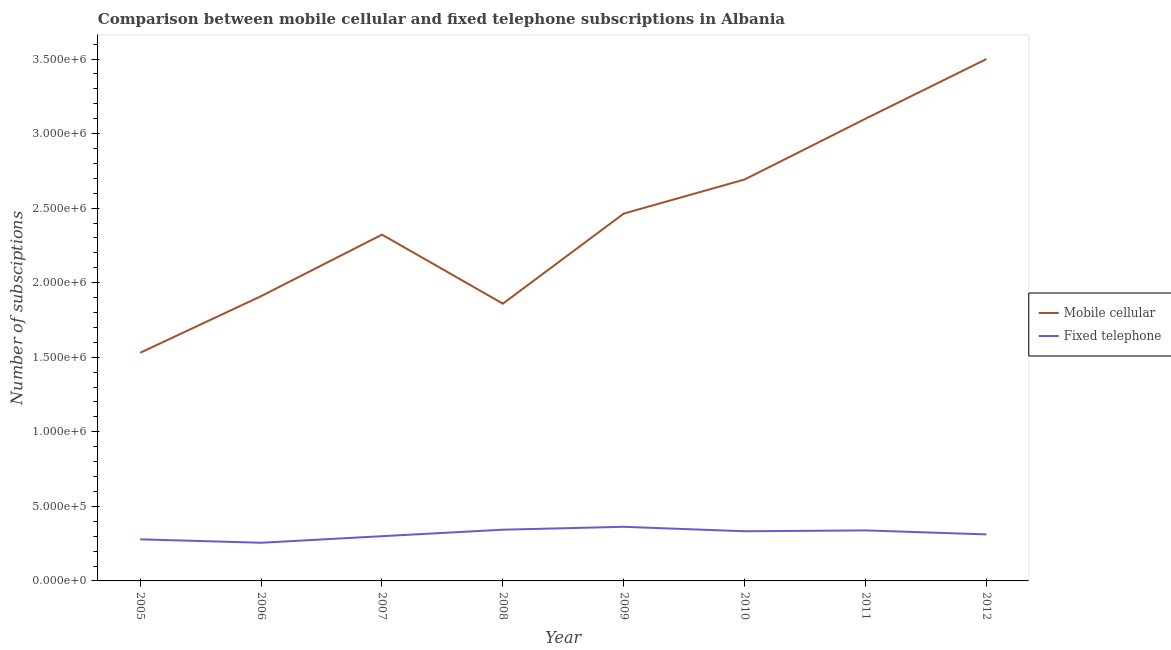How many different coloured lines are there?
Offer a very short reply. 2. Is the number of lines equal to the number of legend labels?
Make the answer very short. Yes. What is the number of fixed telephone subscriptions in 2006?
Your response must be concise. 2.56e+05. Across all years, what is the maximum number of fixed telephone subscriptions?
Your answer should be very brief. 3.63e+05. Across all years, what is the minimum number of mobile cellular subscriptions?
Your response must be concise. 1.53e+06. In which year was the number of mobile cellular subscriptions maximum?
Offer a terse response. 2012. What is the total number of mobile cellular subscriptions in the graph?
Your answer should be very brief. 1.94e+07. What is the difference between the number of mobile cellular subscriptions in 2009 and that in 2011?
Your answer should be very brief. -6.36e+05. What is the difference between the number of mobile cellular subscriptions in 2007 and the number of fixed telephone subscriptions in 2005?
Offer a terse response. 2.04e+06. What is the average number of fixed telephone subscriptions per year?
Your answer should be very brief. 3.16e+05. In the year 2010, what is the difference between the number of fixed telephone subscriptions and number of mobile cellular subscriptions?
Make the answer very short. -2.36e+06. What is the ratio of the number of fixed telephone subscriptions in 2006 to that in 2009?
Ensure brevity in your answer.  0.71. Is the difference between the number of fixed telephone subscriptions in 2005 and 2011 greater than the difference between the number of mobile cellular subscriptions in 2005 and 2011?
Ensure brevity in your answer.  Yes. What is the difference between the highest and the lowest number of mobile cellular subscriptions?
Your answer should be very brief. 1.97e+06. Does the number of mobile cellular subscriptions monotonically increase over the years?
Provide a short and direct response. No. How many lines are there?
Keep it short and to the point. 2. What is the difference between two consecutive major ticks on the Y-axis?
Your response must be concise. 5.00e+05. Are the values on the major ticks of Y-axis written in scientific E-notation?
Your answer should be compact. Yes. Does the graph contain any zero values?
Give a very brief answer. No. Where does the legend appear in the graph?
Ensure brevity in your answer.  Center right. How many legend labels are there?
Provide a succinct answer. 2. What is the title of the graph?
Your answer should be compact. Comparison between mobile cellular and fixed telephone subscriptions in Albania. Does "By country of origin" appear as one of the legend labels in the graph?
Keep it short and to the point. No. What is the label or title of the X-axis?
Your answer should be very brief. Year. What is the label or title of the Y-axis?
Your response must be concise. Number of subsciptions. What is the Number of subsciptions of Mobile cellular in 2005?
Keep it short and to the point. 1.53e+06. What is the Number of subsciptions in Fixed telephone in 2005?
Give a very brief answer. 2.79e+05. What is the Number of subsciptions of Mobile cellular in 2006?
Keep it short and to the point. 1.91e+06. What is the Number of subsciptions in Fixed telephone in 2006?
Give a very brief answer. 2.56e+05. What is the Number of subsciptions of Mobile cellular in 2007?
Make the answer very short. 2.32e+06. What is the Number of subsciptions of Mobile cellular in 2008?
Provide a short and direct response. 1.86e+06. What is the Number of subsciptions of Fixed telephone in 2008?
Your answer should be very brief. 3.44e+05. What is the Number of subsciptions of Mobile cellular in 2009?
Provide a short and direct response. 2.46e+06. What is the Number of subsciptions in Fixed telephone in 2009?
Keep it short and to the point. 3.63e+05. What is the Number of subsciptions of Mobile cellular in 2010?
Your answer should be compact. 2.69e+06. What is the Number of subsciptions of Fixed telephone in 2010?
Ensure brevity in your answer.  3.33e+05. What is the Number of subsciptions in Mobile cellular in 2011?
Offer a terse response. 3.10e+06. What is the Number of subsciptions of Fixed telephone in 2011?
Your answer should be very brief. 3.39e+05. What is the Number of subsciptions of Mobile cellular in 2012?
Your answer should be very brief. 3.50e+06. What is the Number of subsciptions of Fixed telephone in 2012?
Your answer should be very brief. 3.12e+05. Across all years, what is the maximum Number of subsciptions in Mobile cellular?
Offer a very short reply. 3.50e+06. Across all years, what is the maximum Number of subsciptions in Fixed telephone?
Your answer should be very brief. 3.63e+05. Across all years, what is the minimum Number of subsciptions in Mobile cellular?
Offer a terse response. 1.53e+06. Across all years, what is the minimum Number of subsciptions of Fixed telephone?
Keep it short and to the point. 2.56e+05. What is the total Number of subsciptions in Mobile cellular in the graph?
Your answer should be very brief. 1.94e+07. What is the total Number of subsciptions of Fixed telephone in the graph?
Provide a short and direct response. 2.53e+06. What is the difference between the Number of subsciptions in Mobile cellular in 2005 and that in 2006?
Ensure brevity in your answer.  -3.80e+05. What is the difference between the Number of subsciptions in Fixed telephone in 2005 and that in 2006?
Provide a succinct answer. 2.30e+04. What is the difference between the Number of subsciptions of Mobile cellular in 2005 and that in 2007?
Your answer should be very brief. -7.92e+05. What is the difference between the Number of subsciptions of Fixed telephone in 2005 and that in 2007?
Offer a very short reply. -2.10e+04. What is the difference between the Number of subsciptions of Mobile cellular in 2005 and that in 2008?
Provide a short and direct response. -3.29e+05. What is the difference between the Number of subsciptions in Fixed telephone in 2005 and that in 2008?
Provide a short and direct response. -6.46e+04. What is the difference between the Number of subsciptions of Mobile cellular in 2005 and that in 2009?
Provide a succinct answer. -9.33e+05. What is the difference between the Number of subsciptions in Fixed telephone in 2005 and that in 2009?
Your answer should be compact. -8.40e+04. What is the difference between the Number of subsciptions of Mobile cellular in 2005 and that in 2010?
Your answer should be very brief. -1.16e+06. What is the difference between the Number of subsciptions of Fixed telephone in 2005 and that in 2010?
Offer a very short reply. -5.41e+04. What is the difference between the Number of subsciptions in Mobile cellular in 2005 and that in 2011?
Your answer should be compact. -1.57e+06. What is the difference between the Number of subsciptions in Fixed telephone in 2005 and that in 2011?
Give a very brief answer. -5.99e+04. What is the difference between the Number of subsciptions of Mobile cellular in 2005 and that in 2012?
Offer a terse response. -1.97e+06. What is the difference between the Number of subsciptions of Fixed telephone in 2005 and that in 2012?
Offer a very short reply. -3.30e+04. What is the difference between the Number of subsciptions of Mobile cellular in 2006 and that in 2007?
Your answer should be very brief. -4.13e+05. What is the difference between the Number of subsciptions in Fixed telephone in 2006 and that in 2007?
Your answer should be very brief. -4.40e+04. What is the difference between the Number of subsciptions of Mobile cellular in 2006 and that in 2008?
Give a very brief answer. 5.03e+04. What is the difference between the Number of subsciptions in Fixed telephone in 2006 and that in 2008?
Make the answer very short. -8.76e+04. What is the difference between the Number of subsciptions of Mobile cellular in 2006 and that in 2009?
Keep it short and to the point. -5.54e+05. What is the difference between the Number of subsciptions of Fixed telephone in 2006 and that in 2009?
Provide a short and direct response. -1.07e+05. What is the difference between the Number of subsciptions in Mobile cellular in 2006 and that in 2010?
Give a very brief answer. -7.82e+05. What is the difference between the Number of subsciptions of Fixed telephone in 2006 and that in 2010?
Provide a succinct answer. -7.71e+04. What is the difference between the Number of subsciptions of Mobile cellular in 2006 and that in 2011?
Give a very brief answer. -1.19e+06. What is the difference between the Number of subsciptions of Fixed telephone in 2006 and that in 2011?
Make the answer very short. -8.28e+04. What is the difference between the Number of subsciptions of Mobile cellular in 2006 and that in 2012?
Your answer should be compact. -1.59e+06. What is the difference between the Number of subsciptions of Fixed telephone in 2006 and that in 2012?
Keep it short and to the point. -5.60e+04. What is the difference between the Number of subsciptions of Mobile cellular in 2007 and that in 2008?
Provide a short and direct response. 4.63e+05. What is the difference between the Number of subsciptions of Fixed telephone in 2007 and that in 2008?
Keep it short and to the point. -4.36e+04. What is the difference between the Number of subsciptions of Mobile cellular in 2007 and that in 2009?
Your response must be concise. -1.41e+05. What is the difference between the Number of subsciptions in Fixed telephone in 2007 and that in 2009?
Your answer should be compact. -6.30e+04. What is the difference between the Number of subsciptions in Mobile cellular in 2007 and that in 2010?
Keep it short and to the point. -3.70e+05. What is the difference between the Number of subsciptions in Fixed telephone in 2007 and that in 2010?
Your response must be concise. -3.31e+04. What is the difference between the Number of subsciptions of Mobile cellular in 2007 and that in 2011?
Your response must be concise. -7.78e+05. What is the difference between the Number of subsciptions in Fixed telephone in 2007 and that in 2011?
Offer a very short reply. -3.88e+04. What is the difference between the Number of subsciptions of Mobile cellular in 2007 and that in 2012?
Your answer should be compact. -1.18e+06. What is the difference between the Number of subsciptions in Fixed telephone in 2007 and that in 2012?
Ensure brevity in your answer.  -1.20e+04. What is the difference between the Number of subsciptions in Mobile cellular in 2008 and that in 2009?
Offer a very short reply. -6.04e+05. What is the difference between the Number of subsciptions of Fixed telephone in 2008 and that in 2009?
Offer a terse response. -1.94e+04. What is the difference between the Number of subsciptions of Mobile cellular in 2008 and that in 2010?
Your response must be concise. -8.33e+05. What is the difference between the Number of subsciptions of Fixed telephone in 2008 and that in 2010?
Ensure brevity in your answer.  1.05e+04. What is the difference between the Number of subsciptions of Mobile cellular in 2008 and that in 2011?
Your answer should be very brief. -1.24e+06. What is the difference between the Number of subsciptions of Fixed telephone in 2008 and that in 2011?
Offer a terse response. 4747. What is the difference between the Number of subsciptions of Mobile cellular in 2008 and that in 2012?
Offer a very short reply. -1.64e+06. What is the difference between the Number of subsciptions in Fixed telephone in 2008 and that in 2012?
Give a very brief answer. 3.16e+04. What is the difference between the Number of subsciptions of Mobile cellular in 2009 and that in 2010?
Give a very brief answer. -2.29e+05. What is the difference between the Number of subsciptions in Fixed telephone in 2009 and that in 2010?
Give a very brief answer. 2.99e+04. What is the difference between the Number of subsciptions in Mobile cellular in 2009 and that in 2011?
Provide a short and direct response. -6.36e+05. What is the difference between the Number of subsciptions in Fixed telephone in 2009 and that in 2011?
Your answer should be compact. 2.42e+04. What is the difference between the Number of subsciptions of Mobile cellular in 2009 and that in 2012?
Offer a very short reply. -1.04e+06. What is the difference between the Number of subsciptions in Fixed telephone in 2009 and that in 2012?
Provide a succinct answer. 5.10e+04. What is the difference between the Number of subsciptions in Mobile cellular in 2010 and that in 2011?
Ensure brevity in your answer.  -4.08e+05. What is the difference between the Number of subsciptions of Fixed telephone in 2010 and that in 2011?
Provide a succinct answer. -5778. What is the difference between the Number of subsciptions in Mobile cellular in 2010 and that in 2012?
Provide a short and direct response. -8.08e+05. What is the difference between the Number of subsciptions in Fixed telephone in 2010 and that in 2012?
Keep it short and to the point. 2.11e+04. What is the difference between the Number of subsciptions of Mobile cellular in 2011 and that in 2012?
Offer a terse response. -4.00e+05. What is the difference between the Number of subsciptions in Fixed telephone in 2011 and that in 2012?
Your answer should be very brief. 2.68e+04. What is the difference between the Number of subsciptions of Mobile cellular in 2005 and the Number of subsciptions of Fixed telephone in 2006?
Offer a terse response. 1.27e+06. What is the difference between the Number of subsciptions in Mobile cellular in 2005 and the Number of subsciptions in Fixed telephone in 2007?
Ensure brevity in your answer.  1.23e+06. What is the difference between the Number of subsciptions in Mobile cellular in 2005 and the Number of subsciptions in Fixed telephone in 2008?
Make the answer very short. 1.19e+06. What is the difference between the Number of subsciptions in Mobile cellular in 2005 and the Number of subsciptions in Fixed telephone in 2009?
Ensure brevity in your answer.  1.17e+06. What is the difference between the Number of subsciptions in Mobile cellular in 2005 and the Number of subsciptions in Fixed telephone in 2010?
Your response must be concise. 1.20e+06. What is the difference between the Number of subsciptions of Mobile cellular in 2005 and the Number of subsciptions of Fixed telephone in 2011?
Provide a succinct answer. 1.19e+06. What is the difference between the Number of subsciptions in Mobile cellular in 2005 and the Number of subsciptions in Fixed telephone in 2012?
Your answer should be very brief. 1.22e+06. What is the difference between the Number of subsciptions of Mobile cellular in 2006 and the Number of subsciptions of Fixed telephone in 2007?
Your response must be concise. 1.61e+06. What is the difference between the Number of subsciptions in Mobile cellular in 2006 and the Number of subsciptions in Fixed telephone in 2008?
Ensure brevity in your answer.  1.57e+06. What is the difference between the Number of subsciptions in Mobile cellular in 2006 and the Number of subsciptions in Fixed telephone in 2009?
Your response must be concise. 1.55e+06. What is the difference between the Number of subsciptions of Mobile cellular in 2006 and the Number of subsciptions of Fixed telephone in 2010?
Provide a succinct answer. 1.58e+06. What is the difference between the Number of subsciptions in Mobile cellular in 2006 and the Number of subsciptions in Fixed telephone in 2011?
Provide a succinct answer. 1.57e+06. What is the difference between the Number of subsciptions in Mobile cellular in 2006 and the Number of subsciptions in Fixed telephone in 2012?
Your response must be concise. 1.60e+06. What is the difference between the Number of subsciptions in Mobile cellular in 2007 and the Number of subsciptions in Fixed telephone in 2008?
Ensure brevity in your answer.  1.98e+06. What is the difference between the Number of subsciptions in Mobile cellular in 2007 and the Number of subsciptions in Fixed telephone in 2009?
Provide a short and direct response. 1.96e+06. What is the difference between the Number of subsciptions of Mobile cellular in 2007 and the Number of subsciptions of Fixed telephone in 2010?
Ensure brevity in your answer.  1.99e+06. What is the difference between the Number of subsciptions of Mobile cellular in 2007 and the Number of subsciptions of Fixed telephone in 2011?
Offer a terse response. 1.98e+06. What is the difference between the Number of subsciptions of Mobile cellular in 2007 and the Number of subsciptions of Fixed telephone in 2012?
Keep it short and to the point. 2.01e+06. What is the difference between the Number of subsciptions in Mobile cellular in 2008 and the Number of subsciptions in Fixed telephone in 2009?
Make the answer very short. 1.50e+06. What is the difference between the Number of subsciptions of Mobile cellular in 2008 and the Number of subsciptions of Fixed telephone in 2010?
Provide a short and direct response. 1.53e+06. What is the difference between the Number of subsciptions of Mobile cellular in 2008 and the Number of subsciptions of Fixed telephone in 2011?
Your answer should be very brief. 1.52e+06. What is the difference between the Number of subsciptions of Mobile cellular in 2008 and the Number of subsciptions of Fixed telephone in 2012?
Ensure brevity in your answer.  1.55e+06. What is the difference between the Number of subsciptions of Mobile cellular in 2009 and the Number of subsciptions of Fixed telephone in 2010?
Give a very brief answer. 2.13e+06. What is the difference between the Number of subsciptions of Mobile cellular in 2009 and the Number of subsciptions of Fixed telephone in 2011?
Your response must be concise. 2.12e+06. What is the difference between the Number of subsciptions in Mobile cellular in 2009 and the Number of subsciptions in Fixed telephone in 2012?
Make the answer very short. 2.15e+06. What is the difference between the Number of subsciptions of Mobile cellular in 2010 and the Number of subsciptions of Fixed telephone in 2011?
Your response must be concise. 2.35e+06. What is the difference between the Number of subsciptions of Mobile cellular in 2010 and the Number of subsciptions of Fixed telephone in 2012?
Offer a terse response. 2.38e+06. What is the difference between the Number of subsciptions of Mobile cellular in 2011 and the Number of subsciptions of Fixed telephone in 2012?
Provide a short and direct response. 2.79e+06. What is the average Number of subsciptions in Mobile cellular per year?
Offer a very short reply. 2.42e+06. What is the average Number of subsciptions in Fixed telephone per year?
Make the answer very short. 3.16e+05. In the year 2005, what is the difference between the Number of subsciptions of Mobile cellular and Number of subsciptions of Fixed telephone?
Give a very brief answer. 1.25e+06. In the year 2006, what is the difference between the Number of subsciptions in Mobile cellular and Number of subsciptions in Fixed telephone?
Your response must be concise. 1.65e+06. In the year 2007, what is the difference between the Number of subsciptions of Mobile cellular and Number of subsciptions of Fixed telephone?
Your answer should be compact. 2.02e+06. In the year 2008, what is the difference between the Number of subsciptions in Mobile cellular and Number of subsciptions in Fixed telephone?
Give a very brief answer. 1.52e+06. In the year 2009, what is the difference between the Number of subsciptions of Mobile cellular and Number of subsciptions of Fixed telephone?
Ensure brevity in your answer.  2.10e+06. In the year 2010, what is the difference between the Number of subsciptions in Mobile cellular and Number of subsciptions in Fixed telephone?
Offer a terse response. 2.36e+06. In the year 2011, what is the difference between the Number of subsciptions of Mobile cellular and Number of subsciptions of Fixed telephone?
Offer a terse response. 2.76e+06. In the year 2012, what is the difference between the Number of subsciptions of Mobile cellular and Number of subsciptions of Fixed telephone?
Make the answer very short. 3.19e+06. What is the ratio of the Number of subsciptions of Mobile cellular in 2005 to that in 2006?
Provide a succinct answer. 0.8. What is the ratio of the Number of subsciptions in Fixed telephone in 2005 to that in 2006?
Make the answer very short. 1.09. What is the ratio of the Number of subsciptions in Mobile cellular in 2005 to that in 2007?
Ensure brevity in your answer.  0.66. What is the ratio of the Number of subsciptions in Fixed telephone in 2005 to that in 2007?
Provide a succinct answer. 0.93. What is the ratio of the Number of subsciptions of Mobile cellular in 2005 to that in 2008?
Your response must be concise. 0.82. What is the ratio of the Number of subsciptions of Fixed telephone in 2005 to that in 2008?
Make the answer very short. 0.81. What is the ratio of the Number of subsciptions of Mobile cellular in 2005 to that in 2009?
Your response must be concise. 0.62. What is the ratio of the Number of subsciptions in Fixed telephone in 2005 to that in 2009?
Keep it short and to the point. 0.77. What is the ratio of the Number of subsciptions in Mobile cellular in 2005 to that in 2010?
Keep it short and to the point. 0.57. What is the ratio of the Number of subsciptions in Fixed telephone in 2005 to that in 2010?
Your response must be concise. 0.84. What is the ratio of the Number of subsciptions of Mobile cellular in 2005 to that in 2011?
Your response must be concise. 0.49. What is the ratio of the Number of subsciptions of Fixed telephone in 2005 to that in 2011?
Give a very brief answer. 0.82. What is the ratio of the Number of subsciptions of Mobile cellular in 2005 to that in 2012?
Provide a short and direct response. 0.44. What is the ratio of the Number of subsciptions of Fixed telephone in 2005 to that in 2012?
Your answer should be compact. 0.89. What is the ratio of the Number of subsciptions of Mobile cellular in 2006 to that in 2007?
Offer a terse response. 0.82. What is the ratio of the Number of subsciptions in Fixed telephone in 2006 to that in 2007?
Offer a terse response. 0.85. What is the ratio of the Number of subsciptions in Fixed telephone in 2006 to that in 2008?
Provide a short and direct response. 0.75. What is the ratio of the Number of subsciptions of Mobile cellular in 2006 to that in 2009?
Keep it short and to the point. 0.78. What is the ratio of the Number of subsciptions of Fixed telephone in 2006 to that in 2009?
Offer a terse response. 0.71. What is the ratio of the Number of subsciptions of Mobile cellular in 2006 to that in 2010?
Your response must be concise. 0.71. What is the ratio of the Number of subsciptions in Fixed telephone in 2006 to that in 2010?
Provide a succinct answer. 0.77. What is the ratio of the Number of subsciptions of Mobile cellular in 2006 to that in 2011?
Make the answer very short. 0.62. What is the ratio of the Number of subsciptions of Fixed telephone in 2006 to that in 2011?
Provide a short and direct response. 0.76. What is the ratio of the Number of subsciptions in Mobile cellular in 2006 to that in 2012?
Offer a terse response. 0.55. What is the ratio of the Number of subsciptions in Fixed telephone in 2006 to that in 2012?
Make the answer very short. 0.82. What is the ratio of the Number of subsciptions in Mobile cellular in 2007 to that in 2008?
Your answer should be very brief. 1.25. What is the ratio of the Number of subsciptions of Fixed telephone in 2007 to that in 2008?
Offer a terse response. 0.87. What is the ratio of the Number of subsciptions of Mobile cellular in 2007 to that in 2009?
Your response must be concise. 0.94. What is the ratio of the Number of subsciptions of Fixed telephone in 2007 to that in 2009?
Make the answer very short. 0.83. What is the ratio of the Number of subsciptions in Mobile cellular in 2007 to that in 2010?
Make the answer very short. 0.86. What is the ratio of the Number of subsciptions in Fixed telephone in 2007 to that in 2010?
Make the answer very short. 0.9. What is the ratio of the Number of subsciptions of Mobile cellular in 2007 to that in 2011?
Your response must be concise. 0.75. What is the ratio of the Number of subsciptions of Fixed telephone in 2007 to that in 2011?
Your answer should be very brief. 0.89. What is the ratio of the Number of subsciptions of Mobile cellular in 2007 to that in 2012?
Provide a succinct answer. 0.66. What is the ratio of the Number of subsciptions in Fixed telephone in 2007 to that in 2012?
Provide a short and direct response. 0.96. What is the ratio of the Number of subsciptions of Mobile cellular in 2008 to that in 2009?
Offer a very short reply. 0.75. What is the ratio of the Number of subsciptions in Fixed telephone in 2008 to that in 2009?
Offer a very short reply. 0.95. What is the ratio of the Number of subsciptions of Mobile cellular in 2008 to that in 2010?
Ensure brevity in your answer.  0.69. What is the ratio of the Number of subsciptions of Fixed telephone in 2008 to that in 2010?
Provide a succinct answer. 1.03. What is the ratio of the Number of subsciptions of Mobile cellular in 2008 to that in 2011?
Provide a succinct answer. 0.6. What is the ratio of the Number of subsciptions of Mobile cellular in 2008 to that in 2012?
Give a very brief answer. 0.53. What is the ratio of the Number of subsciptions of Fixed telephone in 2008 to that in 2012?
Your response must be concise. 1.1. What is the ratio of the Number of subsciptions in Mobile cellular in 2009 to that in 2010?
Provide a short and direct response. 0.92. What is the ratio of the Number of subsciptions in Fixed telephone in 2009 to that in 2010?
Your answer should be very brief. 1.09. What is the ratio of the Number of subsciptions of Mobile cellular in 2009 to that in 2011?
Your answer should be compact. 0.79. What is the ratio of the Number of subsciptions of Fixed telephone in 2009 to that in 2011?
Keep it short and to the point. 1.07. What is the ratio of the Number of subsciptions of Mobile cellular in 2009 to that in 2012?
Offer a terse response. 0.7. What is the ratio of the Number of subsciptions of Fixed telephone in 2009 to that in 2012?
Your answer should be compact. 1.16. What is the ratio of the Number of subsciptions in Mobile cellular in 2010 to that in 2011?
Make the answer very short. 0.87. What is the ratio of the Number of subsciptions in Fixed telephone in 2010 to that in 2011?
Your answer should be very brief. 0.98. What is the ratio of the Number of subsciptions in Mobile cellular in 2010 to that in 2012?
Provide a succinct answer. 0.77. What is the ratio of the Number of subsciptions of Fixed telephone in 2010 to that in 2012?
Ensure brevity in your answer.  1.07. What is the ratio of the Number of subsciptions of Mobile cellular in 2011 to that in 2012?
Your response must be concise. 0.89. What is the ratio of the Number of subsciptions in Fixed telephone in 2011 to that in 2012?
Your response must be concise. 1.09. What is the difference between the highest and the second highest Number of subsciptions in Fixed telephone?
Give a very brief answer. 1.94e+04. What is the difference between the highest and the lowest Number of subsciptions in Mobile cellular?
Give a very brief answer. 1.97e+06. What is the difference between the highest and the lowest Number of subsciptions in Fixed telephone?
Offer a very short reply. 1.07e+05. 